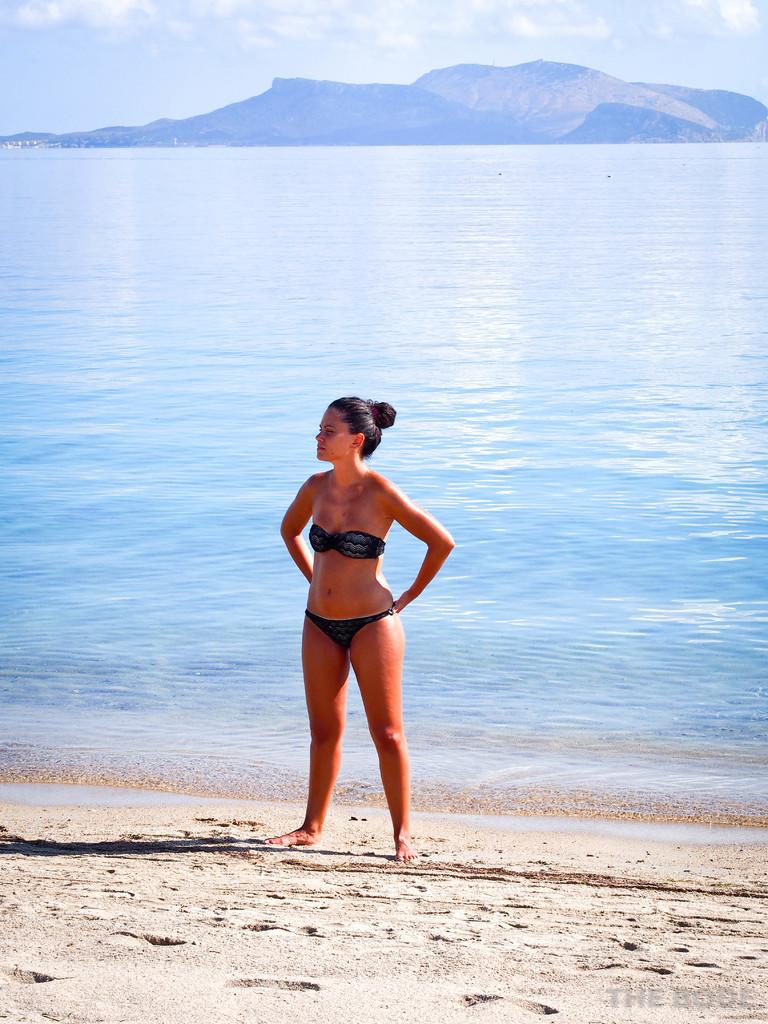What is the woman standing on in the image? The woman is standing on the sand in the image. What natural feature can be seen behind the woman? The sea is visible behind the woman. What type of landform is present in the image? There are hills in the image. What is visible at the top of the image? The sky is visible at the top of the image. Where are the cows grazing in the image? There are no cows present in the image. What type of bird can be seen flying over the hills in the image? There are no birds visible in the image. 